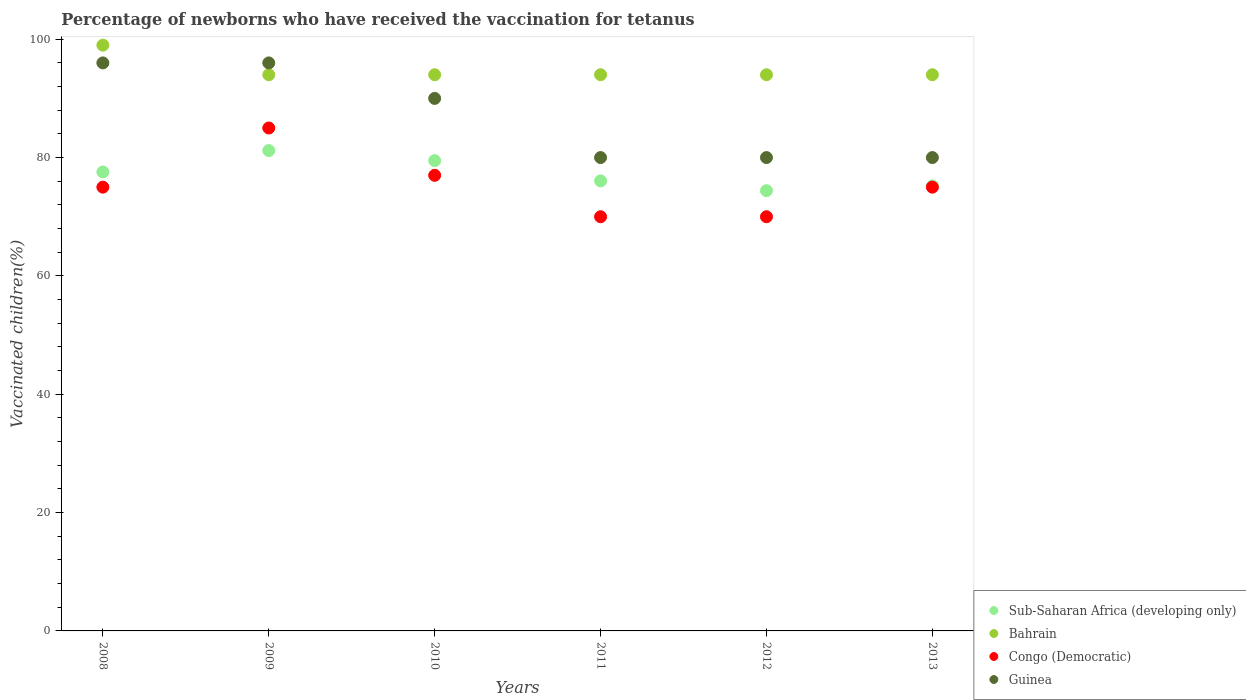What is the percentage of vaccinated children in Congo (Democratic) in 2012?
Offer a very short reply. 70. Across all years, what is the maximum percentage of vaccinated children in Congo (Democratic)?
Your response must be concise. 85. Across all years, what is the minimum percentage of vaccinated children in Sub-Saharan Africa (developing only)?
Offer a very short reply. 74.41. In which year was the percentage of vaccinated children in Congo (Democratic) minimum?
Provide a succinct answer. 2011. What is the total percentage of vaccinated children in Sub-Saharan Africa (developing only) in the graph?
Offer a terse response. 463.92. What is the difference between the percentage of vaccinated children in Congo (Democratic) in 2009 and that in 2013?
Your response must be concise. 10. What is the difference between the percentage of vaccinated children in Congo (Democratic) in 2011 and the percentage of vaccinated children in Bahrain in 2009?
Keep it short and to the point. -24. What is the average percentage of vaccinated children in Sub-Saharan Africa (developing only) per year?
Your answer should be compact. 77.32. In the year 2013, what is the difference between the percentage of vaccinated children in Guinea and percentage of vaccinated children in Bahrain?
Offer a very short reply. -14. In how many years, is the percentage of vaccinated children in Guinea greater than 64 %?
Give a very brief answer. 6. What is the ratio of the percentage of vaccinated children in Bahrain in 2009 to that in 2010?
Your response must be concise. 1. Is the percentage of vaccinated children in Guinea in 2009 less than that in 2011?
Provide a succinct answer. No. What is the difference between the highest and the second highest percentage of vaccinated children in Sub-Saharan Africa (developing only)?
Ensure brevity in your answer.  1.7. What is the difference between the highest and the lowest percentage of vaccinated children in Sub-Saharan Africa (developing only)?
Your answer should be very brief. 6.78. In how many years, is the percentage of vaccinated children in Congo (Democratic) greater than the average percentage of vaccinated children in Congo (Democratic) taken over all years?
Offer a terse response. 2. Is it the case that in every year, the sum of the percentage of vaccinated children in Congo (Democratic) and percentage of vaccinated children in Sub-Saharan Africa (developing only)  is greater than the sum of percentage of vaccinated children in Guinea and percentage of vaccinated children in Bahrain?
Provide a succinct answer. No. Is it the case that in every year, the sum of the percentage of vaccinated children in Bahrain and percentage of vaccinated children in Guinea  is greater than the percentage of vaccinated children in Congo (Democratic)?
Provide a short and direct response. Yes. Does the percentage of vaccinated children in Bahrain monotonically increase over the years?
Offer a terse response. No. What is the difference between two consecutive major ticks on the Y-axis?
Keep it short and to the point. 20. Are the values on the major ticks of Y-axis written in scientific E-notation?
Your answer should be very brief. No. Does the graph contain grids?
Provide a succinct answer. No. Where does the legend appear in the graph?
Make the answer very short. Bottom right. What is the title of the graph?
Ensure brevity in your answer.  Percentage of newborns who have received the vaccination for tetanus. What is the label or title of the Y-axis?
Make the answer very short. Vaccinated children(%). What is the Vaccinated children(%) of Sub-Saharan Africa (developing only) in 2008?
Keep it short and to the point. 77.57. What is the Vaccinated children(%) in Bahrain in 2008?
Offer a terse response. 99. What is the Vaccinated children(%) in Guinea in 2008?
Provide a succinct answer. 96. What is the Vaccinated children(%) in Sub-Saharan Africa (developing only) in 2009?
Offer a terse response. 81.19. What is the Vaccinated children(%) in Bahrain in 2009?
Your answer should be compact. 94. What is the Vaccinated children(%) of Congo (Democratic) in 2009?
Provide a succinct answer. 85. What is the Vaccinated children(%) in Guinea in 2009?
Offer a terse response. 96. What is the Vaccinated children(%) in Sub-Saharan Africa (developing only) in 2010?
Provide a short and direct response. 79.49. What is the Vaccinated children(%) in Bahrain in 2010?
Ensure brevity in your answer.  94. What is the Vaccinated children(%) of Congo (Democratic) in 2010?
Your answer should be compact. 77. What is the Vaccinated children(%) in Guinea in 2010?
Your answer should be very brief. 90. What is the Vaccinated children(%) in Sub-Saharan Africa (developing only) in 2011?
Give a very brief answer. 76.06. What is the Vaccinated children(%) of Bahrain in 2011?
Provide a short and direct response. 94. What is the Vaccinated children(%) in Congo (Democratic) in 2011?
Your answer should be very brief. 70. What is the Vaccinated children(%) in Sub-Saharan Africa (developing only) in 2012?
Your answer should be compact. 74.41. What is the Vaccinated children(%) of Bahrain in 2012?
Keep it short and to the point. 94. What is the Vaccinated children(%) in Guinea in 2012?
Ensure brevity in your answer.  80. What is the Vaccinated children(%) in Sub-Saharan Africa (developing only) in 2013?
Your answer should be compact. 75.21. What is the Vaccinated children(%) in Bahrain in 2013?
Provide a short and direct response. 94. What is the Vaccinated children(%) of Congo (Democratic) in 2013?
Offer a terse response. 75. What is the Vaccinated children(%) of Guinea in 2013?
Keep it short and to the point. 80. Across all years, what is the maximum Vaccinated children(%) of Sub-Saharan Africa (developing only)?
Keep it short and to the point. 81.19. Across all years, what is the maximum Vaccinated children(%) of Guinea?
Offer a very short reply. 96. Across all years, what is the minimum Vaccinated children(%) of Sub-Saharan Africa (developing only)?
Offer a terse response. 74.41. Across all years, what is the minimum Vaccinated children(%) of Bahrain?
Keep it short and to the point. 94. Across all years, what is the minimum Vaccinated children(%) of Guinea?
Provide a succinct answer. 80. What is the total Vaccinated children(%) in Sub-Saharan Africa (developing only) in the graph?
Your answer should be very brief. 463.92. What is the total Vaccinated children(%) in Bahrain in the graph?
Your answer should be compact. 569. What is the total Vaccinated children(%) in Congo (Democratic) in the graph?
Provide a short and direct response. 452. What is the total Vaccinated children(%) in Guinea in the graph?
Provide a short and direct response. 522. What is the difference between the Vaccinated children(%) in Sub-Saharan Africa (developing only) in 2008 and that in 2009?
Your answer should be compact. -3.62. What is the difference between the Vaccinated children(%) of Congo (Democratic) in 2008 and that in 2009?
Keep it short and to the point. -10. What is the difference between the Vaccinated children(%) of Guinea in 2008 and that in 2009?
Provide a succinct answer. 0. What is the difference between the Vaccinated children(%) in Sub-Saharan Africa (developing only) in 2008 and that in 2010?
Your answer should be compact. -1.92. What is the difference between the Vaccinated children(%) in Bahrain in 2008 and that in 2010?
Offer a very short reply. 5. What is the difference between the Vaccinated children(%) of Sub-Saharan Africa (developing only) in 2008 and that in 2011?
Offer a very short reply. 1.51. What is the difference between the Vaccinated children(%) of Bahrain in 2008 and that in 2011?
Keep it short and to the point. 5. What is the difference between the Vaccinated children(%) in Sub-Saharan Africa (developing only) in 2008 and that in 2012?
Offer a terse response. 3.16. What is the difference between the Vaccinated children(%) in Bahrain in 2008 and that in 2012?
Provide a succinct answer. 5. What is the difference between the Vaccinated children(%) in Guinea in 2008 and that in 2012?
Keep it short and to the point. 16. What is the difference between the Vaccinated children(%) of Sub-Saharan Africa (developing only) in 2008 and that in 2013?
Provide a succinct answer. 2.36. What is the difference between the Vaccinated children(%) of Bahrain in 2008 and that in 2013?
Your response must be concise. 5. What is the difference between the Vaccinated children(%) of Congo (Democratic) in 2008 and that in 2013?
Keep it short and to the point. 0. What is the difference between the Vaccinated children(%) in Guinea in 2008 and that in 2013?
Keep it short and to the point. 16. What is the difference between the Vaccinated children(%) in Sub-Saharan Africa (developing only) in 2009 and that in 2010?
Offer a terse response. 1.7. What is the difference between the Vaccinated children(%) in Bahrain in 2009 and that in 2010?
Provide a short and direct response. 0. What is the difference between the Vaccinated children(%) of Congo (Democratic) in 2009 and that in 2010?
Offer a very short reply. 8. What is the difference between the Vaccinated children(%) of Sub-Saharan Africa (developing only) in 2009 and that in 2011?
Ensure brevity in your answer.  5.13. What is the difference between the Vaccinated children(%) in Guinea in 2009 and that in 2011?
Provide a succinct answer. 16. What is the difference between the Vaccinated children(%) in Sub-Saharan Africa (developing only) in 2009 and that in 2012?
Your response must be concise. 6.78. What is the difference between the Vaccinated children(%) in Guinea in 2009 and that in 2012?
Your answer should be very brief. 16. What is the difference between the Vaccinated children(%) of Sub-Saharan Africa (developing only) in 2009 and that in 2013?
Keep it short and to the point. 5.98. What is the difference between the Vaccinated children(%) in Bahrain in 2009 and that in 2013?
Offer a very short reply. 0. What is the difference between the Vaccinated children(%) in Congo (Democratic) in 2009 and that in 2013?
Offer a terse response. 10. What is the difference between the Vaccinated children(%) of Sub-Saharan Africa (developing only) in 2010 and that in 2011?
Provide a succinct answer. 3.42. What is the difference between the Vaccinated children(%) of Congo (Democratic) in 2010 and that in 2011?
Ensure brevity in your answer.  7. What is the difference between the Vaccinated children(%) of Sub-Saharan Africa (developing only) in 2010 and that in 2012?
Your response must be concise. 5.08. What is the difference between the Vaccinated children(%) of Bahrain in 2010 and that in 2012?
Offer a very short reply. 0. What is the difference between the Vaccinated children(%) of Guinea in 2010 and that in 2012?
Make the answer very short. 10. What is the difference between the Vaccinated children(%) of Sub-Saharan Africa (developing only) in 2010 and that in 2013?
Offer a very short reply. 4.28. What is the difference between the Vaccinated children(%) in Sub-Saharan Africa (developing only) in 2011 and that in 2012?
Give a very brief answer. 1.65. What is the difference between the Vaccinated children(%) in Bahrain in 2011 and that in 2012?
Provide a succinct answer. 0. What is the difference between the Vaccinated children(%) in Guinea in 2011 and that in 2012?
Your response must be concise. 0. What is the difference between the Vaccinated children(%) of Sub-Saharan Africa (developing only) in 2011 and that in 2013?
Ensure brevity in your answer.  0.85. What is the difference between the Vaccinated children(%) of Bahrain in 2011 and that in 2013?
Give a very brief answer. 0. What is the difference between the Vaccinated children(%) of Congo (Democratic) in 2011 and that in 2013?
Provide a succinct answer. -5. What is the difference between the Vaccinated children(%) in Guinea in 2011 and that in 2013?
Make the answer very short. 0. What is the difference between the Vaccinated children(%) of Sub-Saharan Africa (developing only) in 2012 and that in 2013?
Provide a short and direct response. -0.8. What is the difference between the Vaccinated children(%) of Congo (Democratic) in 2012 and that in 2013?
Offer a very short reply. -5. What is the difference between the Vaccinated children(%) of Sub-Saharan Africa (developing only) in 2008 and the Vaccinated children(%) of Bahrain in 2009?
Offer a terse response. -16.43. What is the difference between the Vaccinated children(%) in Sub-Saharan Africa (developing only) in 2008 and the Vaccinated children(%) in Congo (Democratic) in 2009?
Ensure brevity in your answer.  -7.43. What is the difference between the Vaccinated children(%) of Sub-Saharan Africa (developing only) in 2008 and the Vaccinated children(%) of Guinea in 2009?
Make the answer very short. -18.43. What is the difference between the Vaccinated children(%) of Bahrain in 2008 and the Vaccinated children(%) of Guinea in 2009?
Your response must be concise. 3. What is the difference between the Vaccinated children(%) in Congo (Democratic) in 2008 and the Vaccinated children(%) in Guinea in 2009?
Provide a succinct answer. -21. What is the difference between the Vaccinated children(%) in Sub-Saharan Africa (developing only) in 2008 and the Vaccinated children(%) in Bahrain in 2010?
Give a very brief answer. -16.43. What is the difference between the Vaccinated children(%) of Sub-Saharan Africa (developing only) in 2008 and the Vaccinated children(%) of Congo (Democratic) in 2010?
Provide a succinct answer. 0.57. What is the difference between the Vaccinated children(%) of Sub-Saharan Africa (developing only) in 2008 and the Vaccinated children(%) of Guinea in 2010?
Offer a terse response. -12.43. What is the difference between the Vaccinated children(%) in Bahrain in 2008 and the Vaccinated children(%) in Congo (Democratic) in 2010?
Keep it short and to the point. 22. What is the difference between the Vaccinated children(%) of Bahrain in 2008 and the Vaccinated children(%) of Guinea in 2010?
Offer a very short reply. 9. What is the difference between the Vaccinated children(%) of Congo (Democratic) in 2008 and the Vaccinated children(%) of Guinea in 2010?
Your response must be concise. -15. What is the difference between the Vaccinated children(%) in Sub-Saharan Africa (developing only) in 2008 and the Vaccinated children(%) in Bahrain in 2011?
Make the answer very short. -16.43. What is the difference between the Vaccinated children(%) in Sub-Saharan Africa (developing only) in 2008 and the Vaccinated children(%) in Congo (Democratic) in 2011?
Make the answer very short. 7.57. What is the difference between the Vaccinated children(%) in Sub-Saharan Africa (developing only) in 2008 and the Vaccinated children(%) in Guinea in 2011?
Provide a short and direct response. -2.43. What is the difference between the Vaccinated children(%) of Bahrain in 2008 and the Vaccinated children(%) of Guinea in 2011?
Give a very brief answer. 19. What is the difference between the Vaccinated children(%) in Sub-Saharan Africa (developing only) in 2008 and the Vaccinated children(%) in Bahrain in 2012?
Keep it short and to the point. -16.43. What is the difference between the Vaccinated children(%) in Sub-Saharan Africa (developing only) in 2008 and the Vaccinated children(%) in Congo (Democratic) in 2012?
Offer a terse response. 7.57. What is the difference between the Vaccinated children(%) in Sub-Saharan Africa (developing only) in 2008 and the Vaccinated children(%) in Guinea in 2012?
Offer a very short reply. -2.43. What is the difference between the Vaccinated children(%) in Sub-Saharan Africa (developing only) in 2008 and the Vaccinated children(%) in Bahrain in 2013?
Your answer should be compact. -16.43. What is the difference between the Vaccinated children(%) in Sub-Saharan Africa (developing only) in 2008 and the Vaccinated children(%) in Congo (Democratic) in 2013?
Make the answer very short. 2.57. What is the difference between the Vaccinated children(%) of Sub-Saharan Africa (developing only) in 2008 and the Vaccinated children(%) of Guinea in 2013?
Provide a short and direct response. -2.43. What is the difference between the Vaccinated children(%) in Bahrain in 2008 and the Vaccinated children(%) in Congo (Democratic) in 2013?
Offer a very short reply. 24. What is the difference between the Vaccinated children(%) in Congo (Democratic) in 2008 and the Vaccinated children(%) in Guinea in 2013?
Provide a succinct answer. -5. What is the difference between the Vaccinated children(%) of Sub-Saharan Africa (developing only) in 2009 and the Vaccinated children(%) of Bahrain in 2010?
Your answer should be compact. -12.81. What is the difference between the Vaccinated children(%) of Sub-Saharan Africa (developing only) in 2009 and the Vaccinated children(%) of Congo (Democratic) in 2010?
Keep it short and to the point. 4.19. What is the difference between the Vaccinated children(%) in Sub-Saharan Africa (developing only) in 2009 and the Vaccinated children(%) in Guinea in 2010?
Your response must be concise. -8.81. What is the difference between the Vaccinated children(%) of Bahrain in 2009 and the Vaccinated children(%) of Congo (Democratic) in 2010?
Your response must be concise. 17. What is the difference between the Vaccinated children(%) in Bahrain in 2009 and the Vaccinated children(%) in Guinea in 2010?
Offer a very short reply. 4. What is the difference between the Vaccinated children(%) in Sub-Saharan Africa (developing only) in 2009 and the Vaccinated children(%) in Bahrain in 2011?
Your answer should be very brief. -12.81. What is the difference between the Vaccinated children(%) of Sub-Saharan Africa (developing only) in 2009 and the Vaccinated children(%) of Congo (Democratic) in 2011?
Your answer should be compact. 11.19. What is the difference between the Vaccinated children(%) of Sub-Saharan Africa (developing only) in 2009 and the Vaccinated children(%) of Guinea in 2011?
Your answer should be compact. 1.19. What is the difference between the Vaccinated children(%) of Bahrain in 2009 and the Vaccinated children(%) of Guinea in 2011?
Make the answer very short. 14. What is the difference between the Vaccinated children(%) in Congo (Democratic) in 2009 and the Vaccinated children(%) in Guinea in 2011?
Provide a short and direct response. 5. What is the difference between the Vaccinated children(%) of Sub-Saharan Africa (developing only) in 2009 and the Vaccinated children(%) of Bahrain in 2012?
Keep it short and to the point. -12.81. What is the difference between the Vaccinated children(%) in Sub-Saharan Africa (developing only) in 2009 and the Vaccinated children(%) in Congo (Democratic) in 2012?
Offer a terse response. 11.19. What is the difference between the Vaccinated children(%) in Sub-Saharan Africa (developing only) in 2009 and the Vaccinated children(%) in Guinea in 2012?
Ensure brevity in your answer.  1.19. What is the difference between the Vaccinated children(%) of Bahrain in 2009 and the Vaccinated children(%) of Congo (Democratic) in 2012?
Make the answer very short. 24. What is the difference between the Vaccinated children(%) in Congo (Democratic) in 2009 and the Vaccinated children(%) in Guinea in 2012?
Offer a very short reply. 5. What is the difference between the Vaccinated children(%) of Sub-Saharan Africa (developing only) in 2009 and the Vaccinated children(%) of Bahrain in 2013?
Offer a very short reply. -12.81. What is the difference between the Vaccinated children(%) in Sub-Saharan Africa (developing only) in 2009 and the Vaccinated children(%) in Congo (Democratic) in 2013?
Your answer should be compact. 6.19. What is the difference between the Vaccinated children(%) of Sub-Saharan Africa (developing only) in 2009 and the Vaccinated children(%) of Guinea in 2013?
Make the answer very short. 1.19. What is the difference between the Vaccinated children(%) of Bahrain in 2009 and the Vaccinated children(%) of Congo (Democratic) in 2013?
Ensure brevity in your answer.  19. What is the difference between the Vaccinated children(%) of Bahrain in 2009 and the Vaccinated children(%) of Guinea in 2013?
Your answer should be compact. 14. What is the difference between the Vaccinated children(%) of Sub-Saharan Africa (developing only) in 2010 and the Vaccinated children(%) of Bahrain in 2011?
Offer a very short reply. -14.51. What is the difference between the Vaccinated children(%) in Sub-Saharan Africa (developing only) in 2010 and the Vaccinated children(%) in Congo (Democratic) in 2011?
Offer a terse response. 9.49. What is the difference between the Vaccinated children(%) in Sub-Saharan Africa (developing only) in 2010 and the Vaccinated children(%) in Guinea in 2011?
Your response must be concise. -0.51. What is the difference between the Vaccinated children(%) in Bahrain in 2010 and the Vaccinated children(%) in Congo (Democratic) in 2011?
Provide a succinct answer. 24. What is the difference between the Vaccinated children(%) in Congo (Democratic) in 2010 and the Vaccinated children(%) in Guinea in 2011?
Your answer should be compact. -3. What is the difference between the Vaccinated children(%) of Sub-Saharan Africa (developing only) in 2010 and the Vaccinated children(%) of Bahrain in 2012?
Your answer should be very brief. -14.51. What is the difference between the Vaccinated children(%) in Sub-Saharan Africa (developing only) in 2010 and the Vaccinated children(%) in Congo (Democratic) in 2012?
Give a very brief answer. 9.49. What is the difference between the Vaccinated children(%) in Sub-Saharan Africa (developing only) in 2010 and the Vaccinated children(%) in Guinea in 2012?
Provide a short and direct response. -0.51. What is the difference between the Vaccinated children(%) in Bahrain in 2010 and the Vaccinated children(%) in Congo (Democratic) in 2012?
Keep it short and to the point. 24. What is the difference between the Vaccinated children(%) in Bahrain in 2010 and the Vaccinated children(%) in Guinea in 2012?
Ensure brevity in your answer.  14. What is the difference between the Vaccinated children(%) in Congo (Democratic) in 2010 and the Vaccinated children(%) in Guinea in 2012?
Provide a succinct answer. -3. What is the difference between the Vaccinated children(%) of Sub-Saharan Africa (developing only) in 2010 and the Vaccinated children(%) of Bahrain in 2013?
Provide a succinct answer. -14.51. What is the difference between the Vaccinated children(%) of Sub-Saharan Africa (developing only) in 2010 and the Vaccinated children(%) of Congo (Democratic) in 2013?
Your response must be concise. 4.49. What is the difference between the Vaccinated children(%) of Sub-Saharan Africa (developing only) in 2010 and the Vaccinated children(%) of Guinea in 2013?
Give a very brief answer. -0.51. What is the difference between the Vaccinated children(%) in Bahrain in 2010 and the Vaccinated children(%) in Congo (Democratic) in 2013?
Give a very brief answer. 19. What is the difference between the Vaccinated children(%) of Bahrain in 2010 and the Vaccinated children(%) of Guinea in 2013?
Ensure brevity in your answer.  14. What is the difference between the Vaccinated children(%) in Congo (Democratic) in 2010 and the Vaccinated children(%) in Guinea in 2013?
Your answer should be very brief. -3. What is the difference between the Vaccinated children(%) of Sub-Saharan Africa (developing only) in 2011 and the Vaccinated children(%) of Bahrain in 2012?
Provide a short and direct response. -17.94. What is the difference between the Vaccinated children(%) in Sub-Saharan Africa (developing only) in 2011 and the Vaccinated children(%) in Congo (Democratic) in 2012?
Your response must be concise. 6.06. What is the difference between the Vaccinated children(%) in Sub-Saharan Africa (developing only) in 2011 and the Vaccinated children(%) in Guinea in 2012?
Make the answer very short. -3.94. What is the difference between the Vaccinated children(%) of Bahrain in 2011 and the Vaccinated children(%) of Congo (Democratic) in 2012?
Give a very brief answer. 24. What is the difference between the Vaccinated children(%) of Bahrain in 2011 and the Vaccinated children(%) of Guinea in 2012?
Offer a very short reply. 14. What is the difference between the Vaccinated children(%) in Congo (Democratic) in 2011 and the Vaccinated children(%) in Guinea in 2012?
Provide a succinct answer. -10. What is the difference between the Vaccinated children(%) in Sub-Saharan Africa (developing only) in 2011 and the Vaccinated children(%) in Bahrain in 2013?
Keep it short and to the point. -17.94. What is the difference between the Vaccinated children(%) in Sub-Saharan Africa (developing only) in 2011 and the Vaccinated children(%) in Congo (Democratic) in 2013?
Ensure brevity in your answer.  1.06. What is the difference between the Vaccinated children(%) of Sub-Saharan Africa (developing only) in 2011 and the Vaccinated children(%) of Guinea in 2013?
Offer a very short reply. -3.94. What is the difference between the Vaccinated children(%) of Bahrain in 2011 and the Vaccinated children(%) of Guinea in 2013?
Make the answer very short. 14. What is the difference between the Vaccinated children(%) in Sub-Saharan Africa (developing only) in 2012 and the Vaccinated children(%) in Bahrain in 2013?
Your answer should be very brief. -19.59. What is the difference between the Vaccinated children(%) in Sub-Saharan Africa (developing only) in 2012 and the Vaccinated children(%) in Congo (Democratic) in 2013?
Ensure brevity in your answer.  -0.59. What is the difference between the Vaccinated children(%) of Sub-Saharan Africa (developing only) in 2012 and the Vaccinated children(%) of Guinea in 2013?
Offer a terse response. -5.59. What is the difference between the Vaccinated children(%) of Bahrain in 2012 and the Vaccinated children(%) of Congo (Democratic) in 2013?
Offer a terse response. 19. What is the difference between the Vaccinated children(%) in Congo (Democratic) in 2012 and the Vaccinated children(%) in Guinea in 2013?
Make the answer very short. -10. What is the average Vaccinated children(%) of Sub-Saharan Africa (developing only) per year?
Offer a very short reply. 77.32. What is the average Vaccinated children(%) in Bahrain per year?
Offer a terse response. 94.83. What is the average Vaccinated children(%) of Congo (Democratic) per year?
Keep it short and to the point. 75.33. What is the average Vaccinated children(%) of Guinea per year?
Your answer should be compact. 87. In the year 2008, what is the difference between the Vaccinated children(%) of Sub-Saharan Africa (developing only) and Vaccinated children(%) of Bahrain?
Keep it short and to the point. -21.43. In the year 2008, what is the difference between the Vaccinated children(%) of Sub-Saharan Africa (developing only) and Vaccinated children(%) of Congo (Democratic)?
Your response must be concise. 2.57. In the year 2008, what is the difference between the Vaccinated children(%) of Sub-Saharan Africa (developing only) and Vaccinated children(%) of Guinea?
Your answer should be very brief. -18.43. In the year 2008, what is the difference between the Vaccinated children(%) in Bahrain and Vaccinated children(%) in Congo (Democratic)?
Offer a terse response. 24. In the year 2008, what is the difference between the Vaccinated children(%) of Bahrain and Vaccinated children(%) of Guinea?
Your answer should be very brief. 3. In the year 2009, what is the difference between the Vaccinated children(%) of Sub-Saharan Africa (developing only) and Vaccinated children(%) of Bahrain?
Keep it short and to the point. -12.81. In the year 2009, what is the difference between the Vaccinated children(%) of Sub-Saharan Africa (developing only) and Vaccinated children(%) of Congo (Democratic)?
Ensure brevity in your answer.  -3.81. In the year 2009, what is the difference between the Vaccinated children(%) in Sub-Saharan Africa (developing only) and Vaccinated children(%) in Guinea?
Offer a very short reply. -14.81. In the year 2009, what is the difference between the Vaccinated children(%) in Bahrain and Vaccinated children(%) in Congo (Democratic)?
Offer a terse response. 9. In the year 2009, what is the difference between the Vaccinated children(%) of Bahrain and Vaccinated children(%) of Guinea?
Keep it short and to the point. -2. In the year 2010, what is the difference between the Vaccinated children(%) in Sub-Saharan Africa (developing only) and Vaccinated children(%) in Bahrain?
Provide a succinct answer. -14.51. In the year 2010, what is the difference between the Vaccinated children(%) in Sub-Saharan Africa (developing only) and Vaccinated children(%) in Congo (Democratic)?
Ensure brevity in your answer.  2.49. In the year 2010, what is the difference between the Vaccinated children(%) in Sub-Saharan Africa (developing only) and Vaccinated children(%) in Guinea?
Offer a terse response. -10.51. In the year 2011, what is the difference between the Vaccinated children(%) of Sub-Saharan Africa (developing only) and Vaccinated children(%) of Bahrain?
Provide a succinct answer. -17.94. In the year 2011, what is the difference between the Vaccinated children(%) in Sub-Saharan Africa (developing only) and Vaccinated children(%) in Congo (Democratic)?
Your answer should be compact. 6.06. In the year 2011, what is the difference between the Vaccinated children(%) of Sub-Saharan Africa (developing only) and Vaccinated children(%) of Guinea?
Keep it short and to the point. -3.94. In the year 2011, what is the difference between the Vaccinated children(%) in Bahrain and Vaccinated children(%) in Guinea?
Provide a short and direct response. 14. In the year 2011, what is the difference between the Vaccinated children(%) of Congo (Democratic) and Vaccinated children(%) of Guinea?
Ensure brevity in your answer.  -10. In the year 2012, what is the difference between the Vaccinated children(%) in Sub-Saharan Africa (developing only) and Vaccinated children(%) in Bahrain?
Ensure brevity in your answer.  -19.59. In the year 2012, what is the difference between the Vaccinated children(%) of Sub-Saharan Africa (developing only) and Vaccinated children(%) of Congo (Democratic)?
Provide a succinct answer. 4.41. In the year 2012, what is the difference between the Vaccinated children(%) of Sub-Saharan Africa (developing only) and Vaccinated children(%) of Guinea?
Provide a short and direct response. -5.59. In the year 2013, what is the difference between the Vaccinated children(%) of Sub-Saharan Africa (developing only) and Vaccinated children(%) of Bahrain?
Provide a short and direct response. -18.79. In the year 2013, what is the difference between the Vaccinated children(%) of Sub-Saharan Africa (developing only) and Vaccinated children(%) of Congo (Democratic)?
Provide a succinct answer. 0.21. In the year 2013, what is the difference between the Vaccinated children(%) of Sub-Saharan Africa (developing only) and Vaccinated children(%) of Guinea?
Offer a terse response. -4.79. What is the ratio of the Vaccinated children(%) of Sub-Saharan Africa (developing only) in 2008 to that in 2009?
Your answer should be very brief. 0.96. What is the ratio of the Vaccinated children(%) of Bahrain in 2008 to that in 2009?
Provide a succinct answer. 1.05. What is the ratio of the Vaccinated children(%) in Congo (Democratic) in 2008 to that in 2009?
Give a very brief answer. 0.88. What is the ratio of the Vaccinated children(%) in Sub-Saharan Africa (developing only) in 2008 to that in 2010?
Your answer should be very brief. 0.98. What is the ratio of the Vaccinated children(%) of Bahrain in 2008 to that in 2010?
Your answer should be very brief. 1.05. What is the ratio of the Vaccinated children(%) in Guinea in 2008 to that in 2010?
Provide a succinct answer. 1.07. What is the ratio of the Vaccinated children(%) in Sub-Saharan Africa (developing only) in 2008 to that in 2011?
Make the answer very short. 1.02. What is the ratio of the Vaccinated children(%) in Bahrain in 2008 to that in 2011?
Ensure brevity in your answer.  1.05. What is the ratio of the Vaccinated children(%) in Congo (Democratic) in 2008 to that in 2011?
Keep it short and to the point. 1.07. What is the ratio of the Vaccinated children(%) of Guinea in 2008 to that in 2011?
Provide a short and direct response. 1.2. What is the ratio of the Vaccinated children(%) in Sub-Saharan Africa (developing only) in 2008 to that in 2012?
Provide a short and direct response. 1.04. What is the ratio of the Vaccinated children(%) in Bahrain in 2008 to that in 2012?
Make the answer very short. 1.05. What is the ratio of the Vaccinated children(%) of Congo (Democratic) in 2008 to that in 2012?
Provide a short and direct response. 1.07. What is the ratio of the Vaccinated children(%) in Guinea in 2008 to that in 2012?
Give a very brief answer. 1.2. What is the ratio of the Vaccinated children(%) in Sub-Saharan Africa (developing only) in 2008 to that in 2013?
Offer a terse response. 1.03. What is the ratio of the Vaccinated children(%) of Bahrain in 2008 to that in 2013?
Give a very brief answer. 1.05. What is the ratio of the Vaccinated children(%) of Sub-Saharan Africa (developing only) in 2009 to that in 2010?
Your response must be concise. 1.02. What is the ratio of the Vaccinated children(%) in Bahrain in 2009 to that in 2010?
Offer a very short reply. 1. What is the ratio of the Vaccinated children(%) of Congo (Democratic) in 2009 to that in 2010?
Make the answer very short. 1.1. What is the ratio of the Vaccinated children(%) in Guinea in 2009 to that in 2010?
Your response must be concise. 1.07. What is the ratio of the Vaccinated children(%) in Sub-Saharan Africa (developing only) in 2009 to that in 2011?
Your answer should be very brief. 1.07. What is the ratio of the Vaccinated children(%) of Bahrain in 2009 to that in 2011?
Make the answer very short. 1. What is the ratio of the Vaccinated children(%) of Congo (Democratic) in 2009 to that in 2011?
Keep it short and to the point. 1.21. What is the ratio of the Vaccinated children(%) in Sub-Saharan Africa (developing only) in 2009 to that in 2012?
Keep it short and to the point. 1.09. What is the ratio of the Vaccinated children(%) in Bahrain in 2009 to that in 2012?
Give a very brief answer. 1. What is the ratio of the Vaccinated children(%) in Congo (Democratic) in 2009 to that in 2012?
Keep it short and to the point. 1.21. What is the ratio of the Vaccinated children(%) of Sub-Saharan Africa (developing only) in 2009 to that in 2013?
Your response must be concise. 1.08. What is the ratio of the Vaccinated children(%) in Bahrain in 2009 to that in 2013?
Keep it short and to the point. 1. What is the ratio of the Vaccinated children(%) in Congo (Democratic) in 2009 to that in 2013?
Provide a short and direct response. 1.13. What is the ratio of the Vaccinated children(%) of Guinea in 2009 to that in 2013?
Your answer should be very brief. 1.2. What is the ratio of the Vaccinated children(%) in Sub-Saharan Africa (developing only) in 2010 to that in 2011?
Give a very brief answer. 1.04. What is the ratio of the Vaccinated children(%) in Bahrain in 2010 to that in 2011?
Provide a succinct answer. 1. What is the ratio of the Vaccinated children(%) of Sub-Saharan Africa (developing only) in 2010 to that in 2012?
Your response must be concise. 1.07. What is the ratio of the Vaccinated children(%) of Bahrain in 2010 to that in 2012?
Offer a very short reply. 1. What is the ratio of the Vaccinated children(%) in Guinea in 2010 to that in 2012?
Ensure brevity in your answer.  1.12. What is the ratio of the Vaccinated children(%) in Sub-Saharan Africa (developing only) in 2010 to that in 2013?
Offer a very short reply. 1.06. What is the ratio of the Vaccinated children(%) in Congo (Democratic) in 2010 to that in 2013?
Make the answer very short. 1.03. What is the ratio of the Vaccinated children(%) of Guinea in 2010 to that in 2013?
Your response must be concise. 1.12. What is the ratio of the Vaccinated children(%) in Sub-Saharan Africa (developing only) in 2011 to that in 2012?
Offer a very short reply. 1.02. What is the ratio of the Vaccinated children(%) of Sub-Saharan Africa (developing only) in 2011 to that in 2013?
Give a very brief answer. 1.01. What is the ratio of the Vaccinated children(%) of Bahrain in 2011 to that in 2013?
Ensure brevity in your answer.  1. What is the ratio of the Vaccinated children(%) of Sub-Saharan Africa (developing only) in 2012 to that in 2013?
Ensure brevity in your answer.  0.99. What is the ratio of the Vaccinated children(%) in Congo (Democratic) in 2012 to that in 2013?
Your response must be concise. 0.93. What is the difference between the highest and the second highest Vaccinated children(%) of Sub-Saharan Africa (developing only)?
Your answer should be compact. 1.7. What is the difference between the highest and the second highest Vaccinated children(%) in Congo (Democratic)?
Give a very brief answer. 8. What is the difference between the highest and the lowest Vaccinated children(%) of Sub-Saharan Africa (developing only)?
Your answer should be very brief. 6.78. What is the difference between the highest and the lowest Vaccinated children(%) in Bahrain?
Give a very brief answer. 5. 